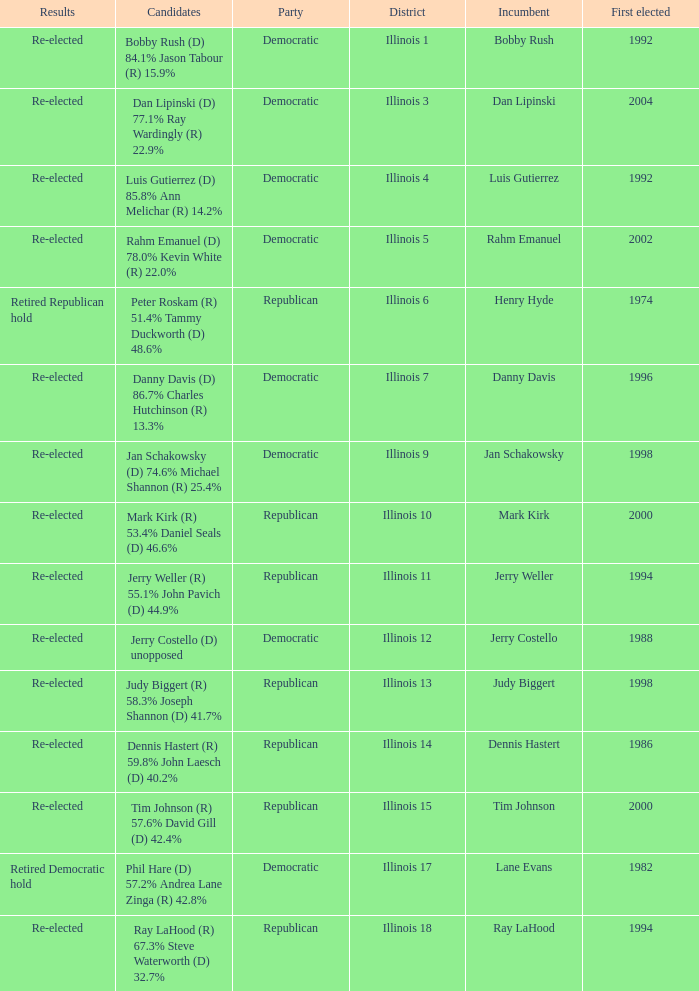What is the district when the first elected was in 1986? Illinois 14. 